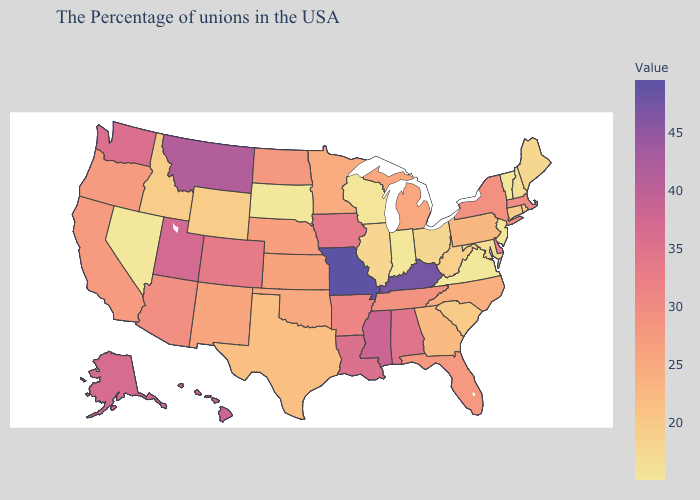Does Missouri have the highest value in the USA?
Concise answer only. Yes. Among the states that border Wyoming , does South Dakota have the lowest value?
Quick response, please. Yes. 